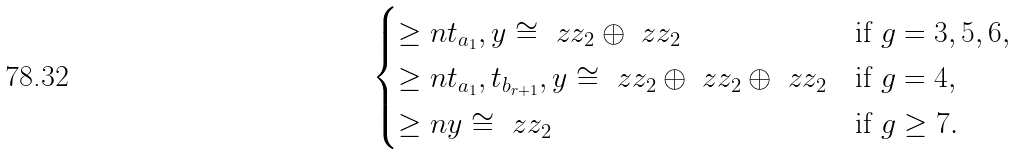Convert formula to latex. <formula><loc_0><loc_0><loc_500><loc_500>\begin{cases} \geq n { t _ { a _ { 1 } } , y } \cong \ z z _ { 2 } \oplus \ z z _ { 2 } & \text {if $g=3,5,6$} , \\ \geq n { t _ { a _ { 1 } } , t _ { b _ { r + 1 } } , y } \cong \ z z _ { 2 } \oplus \ z z _ { 2 } \oplus \ z z _ { 2 } & \text {if $g=4$} , \\ \geq n { y } \cong \ z z _ { 2 } & \text {if $g\geq 7$} . \end{cases}</formula> 